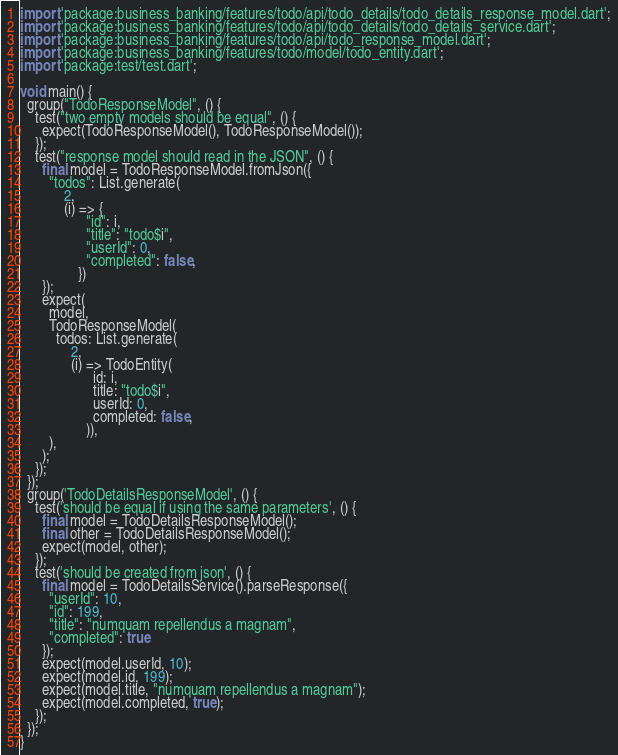<code> <loc_0><loc_0><loc_500><loc_500><_Dart_>import 'package:business_banking/features/todo/api/todo_details/todo_details_response_model.dart';
import 'package:business_banking/features/todo/api/todo_details/todo_details_service.dart';
import 'package:business_banking/features/todo/api/todo_response_model.dart';
import 'package:business_banking/features/todo/model/todo_entity.dart';
import 'package:test/test.dart';

void main() {
  group("TodoResponseModel", () {
    test("two empty models should be equal", () {
      expect(TodoResponseModel(), TodoResponseModel());
    });
    test("response model should read in the JSON", () {
      final model = TodoResponseModel.fromJson({
        "todos": List.generate(
            2,
            (i) => {
                  "id": i,
                  "title": "todo$i",
                  "userId": 0,
                  "completed": false,
                })
      });
      expect(
        model,
        TodoResponseModel(
          todos: List.generate(
              2,
              (i) => TodoEntity(
                    id: i,
                    title: "todo$i",
                    userId: 0,
                    completed: false,
                  )),
        ),
      );
    });
  });
  group('TodoDetailsResponseModel', () {
    test('should be equal if using the same parameters', () {
      final model = TodoDetailsResponseModel();
      final other = TodoDetailsResponseModel();
      expect(model, other);
    });
    test('should be created from json', () {
      final model = TodoDetailsService().parseResponse({
        "userId": 10,
        "id": 199,
        "title": "numquam repellendus a magnam",
        "completed": true
      });
      expect(model.userId, 10);
      expect(model.id, 199);
      expect(model.title, "numquam repellendus a magnam");
      expect(model.completed, true);
    });
  });
}
</code> 